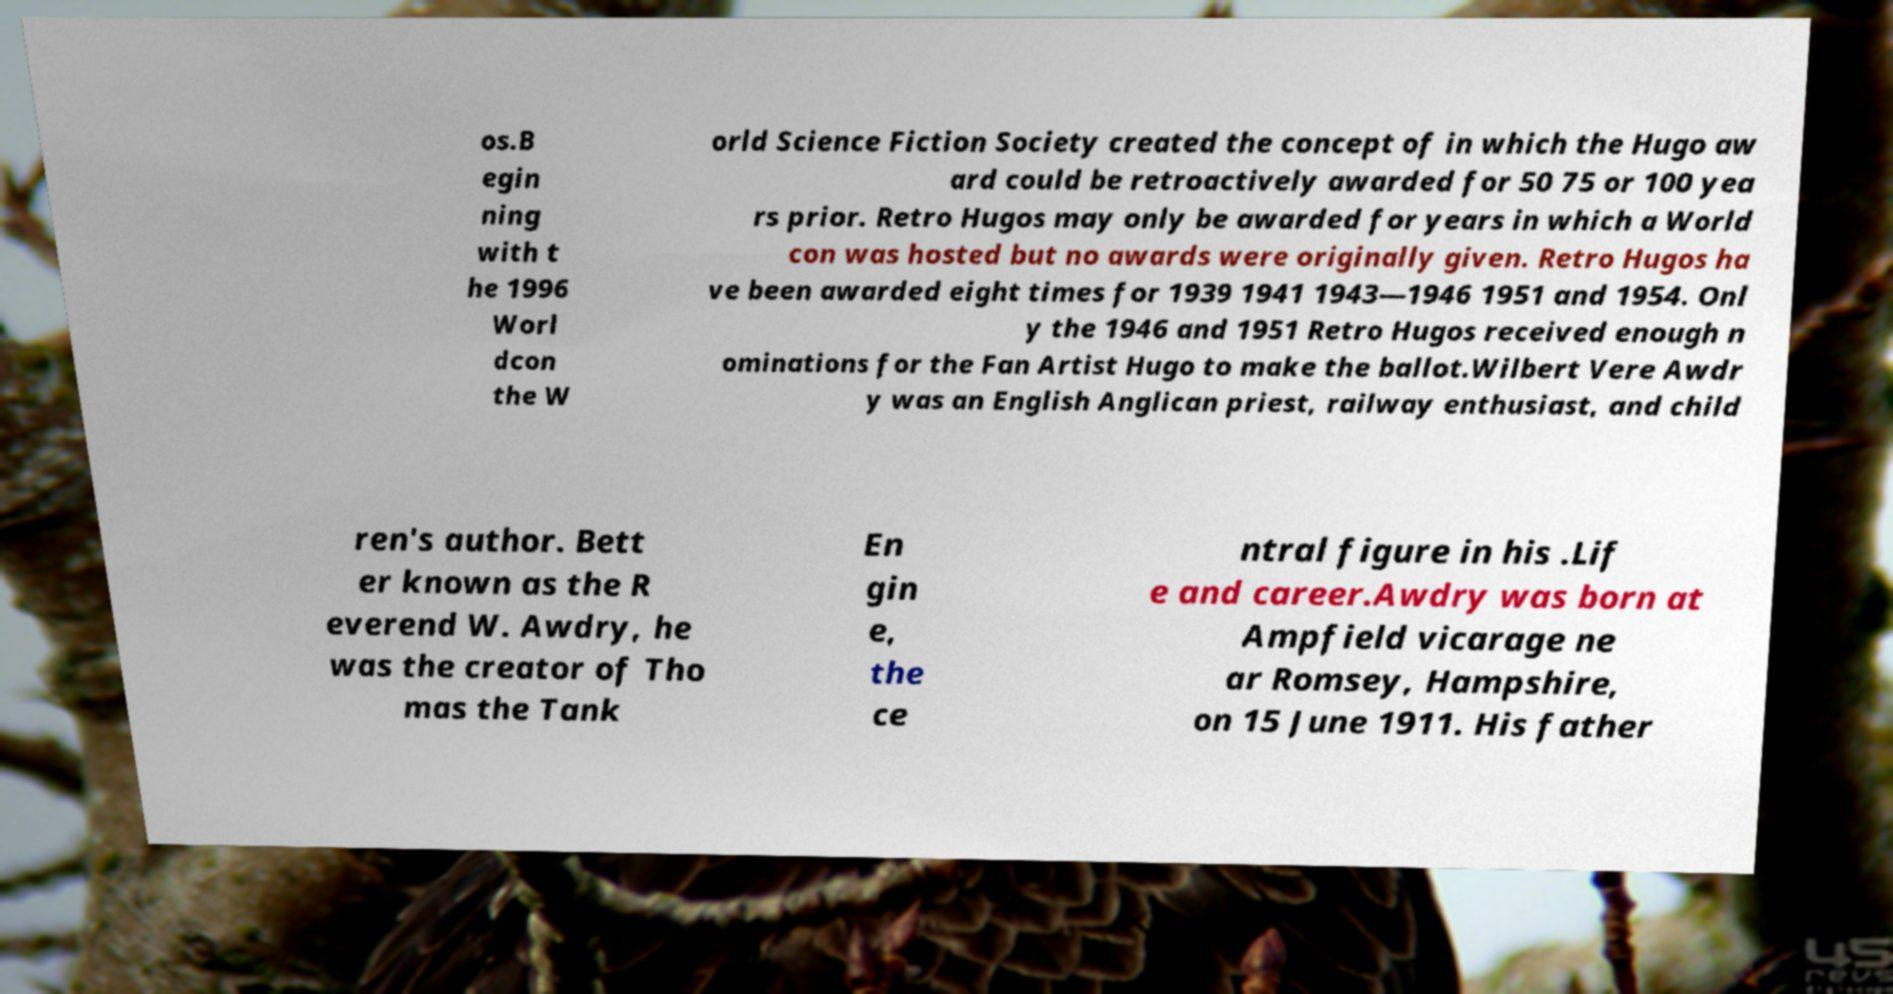Please read and relay the text visible in this image. What does it say? os.B egin ning with t he 1996 Worl dcon the W orld Science Fiction Society created the concept of in which the Hugo aw ard could be retroactively awarded for 50 75 or 100 yea rs prior. Retro Hugos may only be awarded for years in which a World con was hosted but no awards were originally given. Retro Hugos ha ve been awarded eight times for 1939 1941 1943—1946 1951 and 1954. Onl y the 1946 and 1951 Retro Hugos received enough n ominations for the Fan Artist Hugo to make the ballot.Wilbert Vere Awdr y was an English Anglican priest, railway enthusiast, and child ren's author. Bett er known as the R everend W. Awdry, he was the creator of Tho mas the Tank En gin e, the ce ntral figure in his .Lif e and career.Awdry was born at Ampfield vicarage ne ar Romsey, Hampshire, on 15 June 1911. His father 